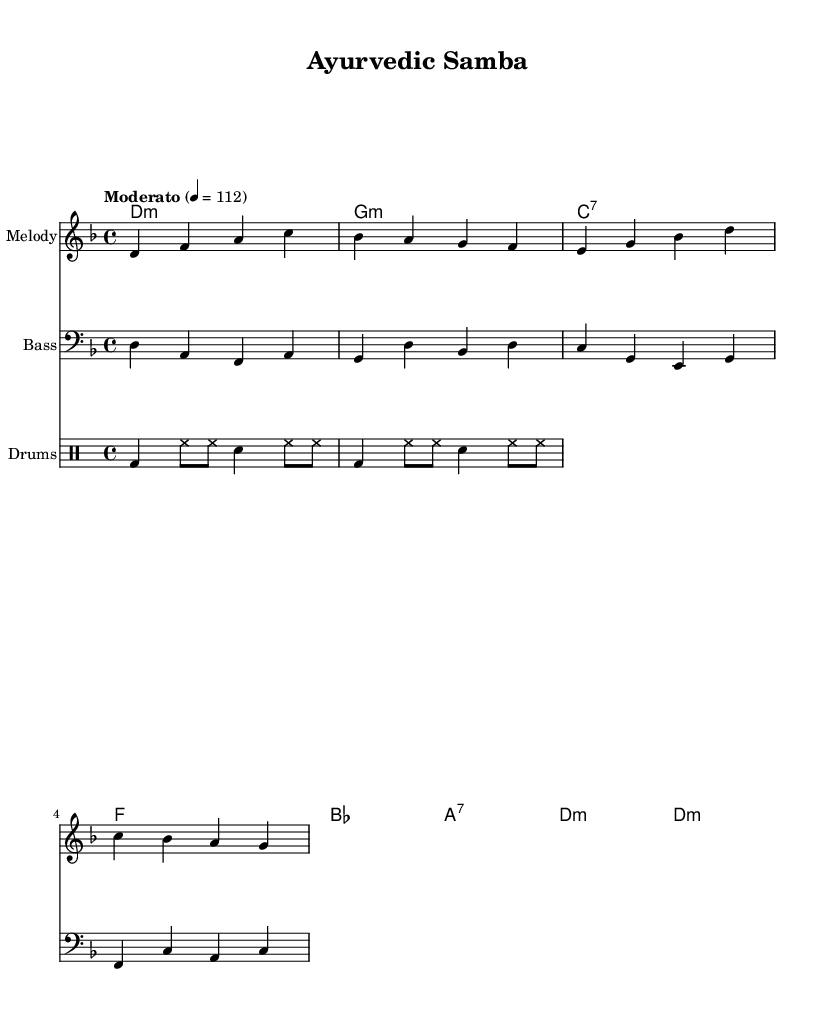What is the key signature of this music? The key signature of the music is D minor, which has one flat (B flat). This can be identified in the music notation system at the beginning of the score, where the key signature is shown.
Answer: D minor What is the time signature? The time signature of this music is four-four, indicated by the symbol at the beginning of the score. It means there are four beats in each measure and the quarter note gets one beat.
Answer: 4/4 What is the tempo marking? The tempo marking indicates "Moderato," which typically denotes a moderate pace. The numerical value given, 4 = 112, implies that there are 112 beats per minute. This can also be deduced from the "Moderato" term in the tempo section of the sheet music.
Answer: Moderato What is the first chord of the piece? The first chord indicated in the harmony part is D minor, shown at the start of the chord progression. It is listed in the chord names section, indicating the harmonic structure.
Answer: D minor How many measures are in the melody section? Counting the measures in the melody section, there are four measures. This can be determined by segmenting the music into counts based on the vertical lines that indicate the ends of the measures.
Answer: 4 What type of jazz is represented in this composition? The composition exemplifies Latin jazz, characterized by its rhythmic and harmonic elements prevalent in Latin music styles, specifically seen in the rhythms and instrumentation outlined in the score.
Answer: Latin jazz 